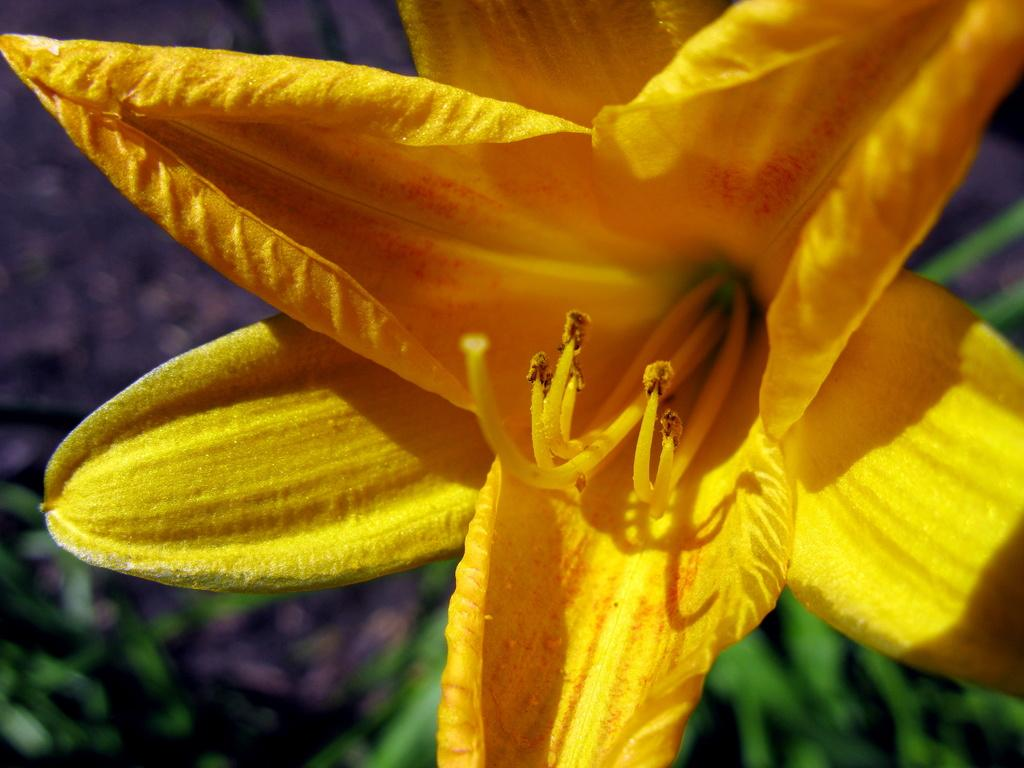What is the main subject of the image? There is a flower in the image. Can you describe the color of the flower? The flower is yellow. What type of honey is the father collecting from the flower in the image? There is no father or honey present in the image; it only features a yellow flower. 